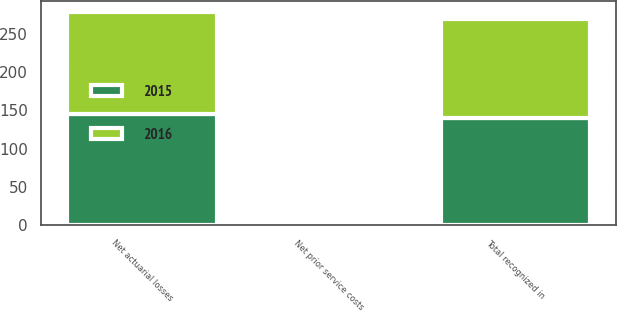<chart> <loc_0><loc_0><loc_500><loc_500><stacked_bar_chart><ecel><fcel>Net actuarial losses<fcel>Net prior service costs<fcel>Total recognized in<nl><fcel>2016<fcel>133.9<fcel>4.5<fcel>129.4<nl><fcel>2015<fcel>144.6<fcel>4.5<fcel>140.1<nl></chart> 